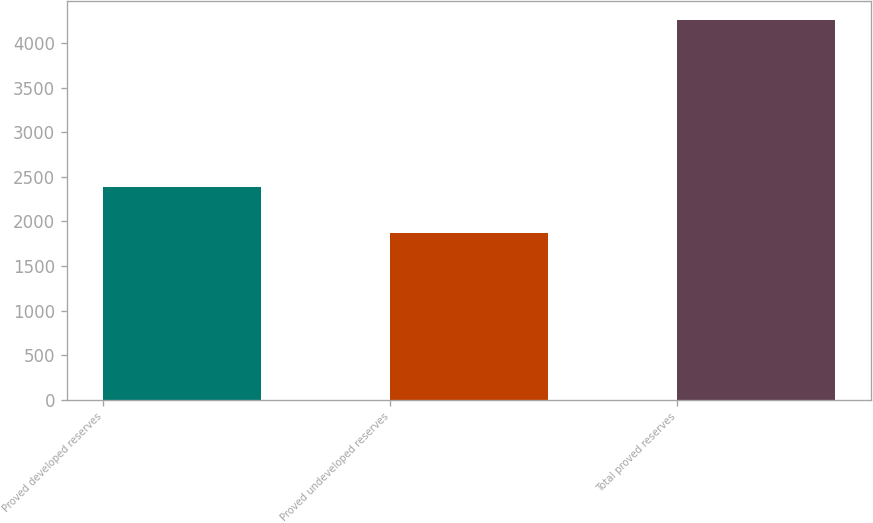<chart> <loc_0><loc_0><loc_500><loc_500><bar_chart><fcel>Proved developed reserves<fcel>Proved undeveloped reserves<fcel>Total proved reserves<nl><fcel>2387<fcel>1868<fcel>4255<nl></chart> 